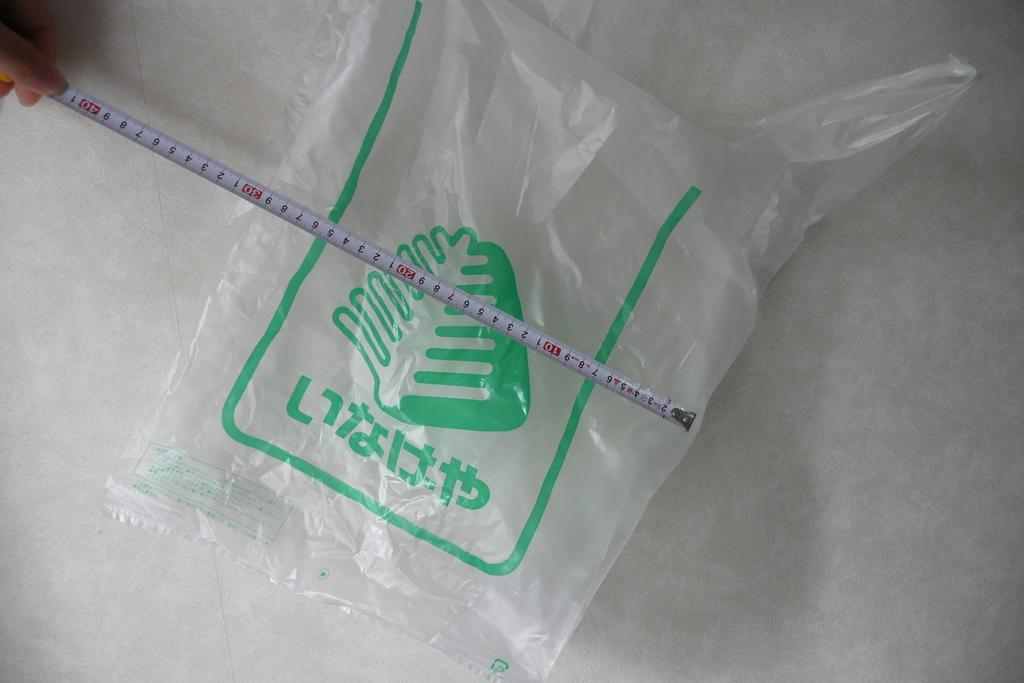What is placed on the floor in the image? There is a cover on the floor in the image. What object is being used in the image? There is a measuring tape in the image. Whose hand is holding the measuring tape? The measuring tape is being held by a hand. How many babies are crawling on the floor with the measuring tape in the image? There are no babies present in the image; it only features a cover on the floor and a measuring tape being held by a hand. What type of rice is being measured with the measuring tape in the image? There is no rice present in the image; it only features a measuring tape being held by a hand. 